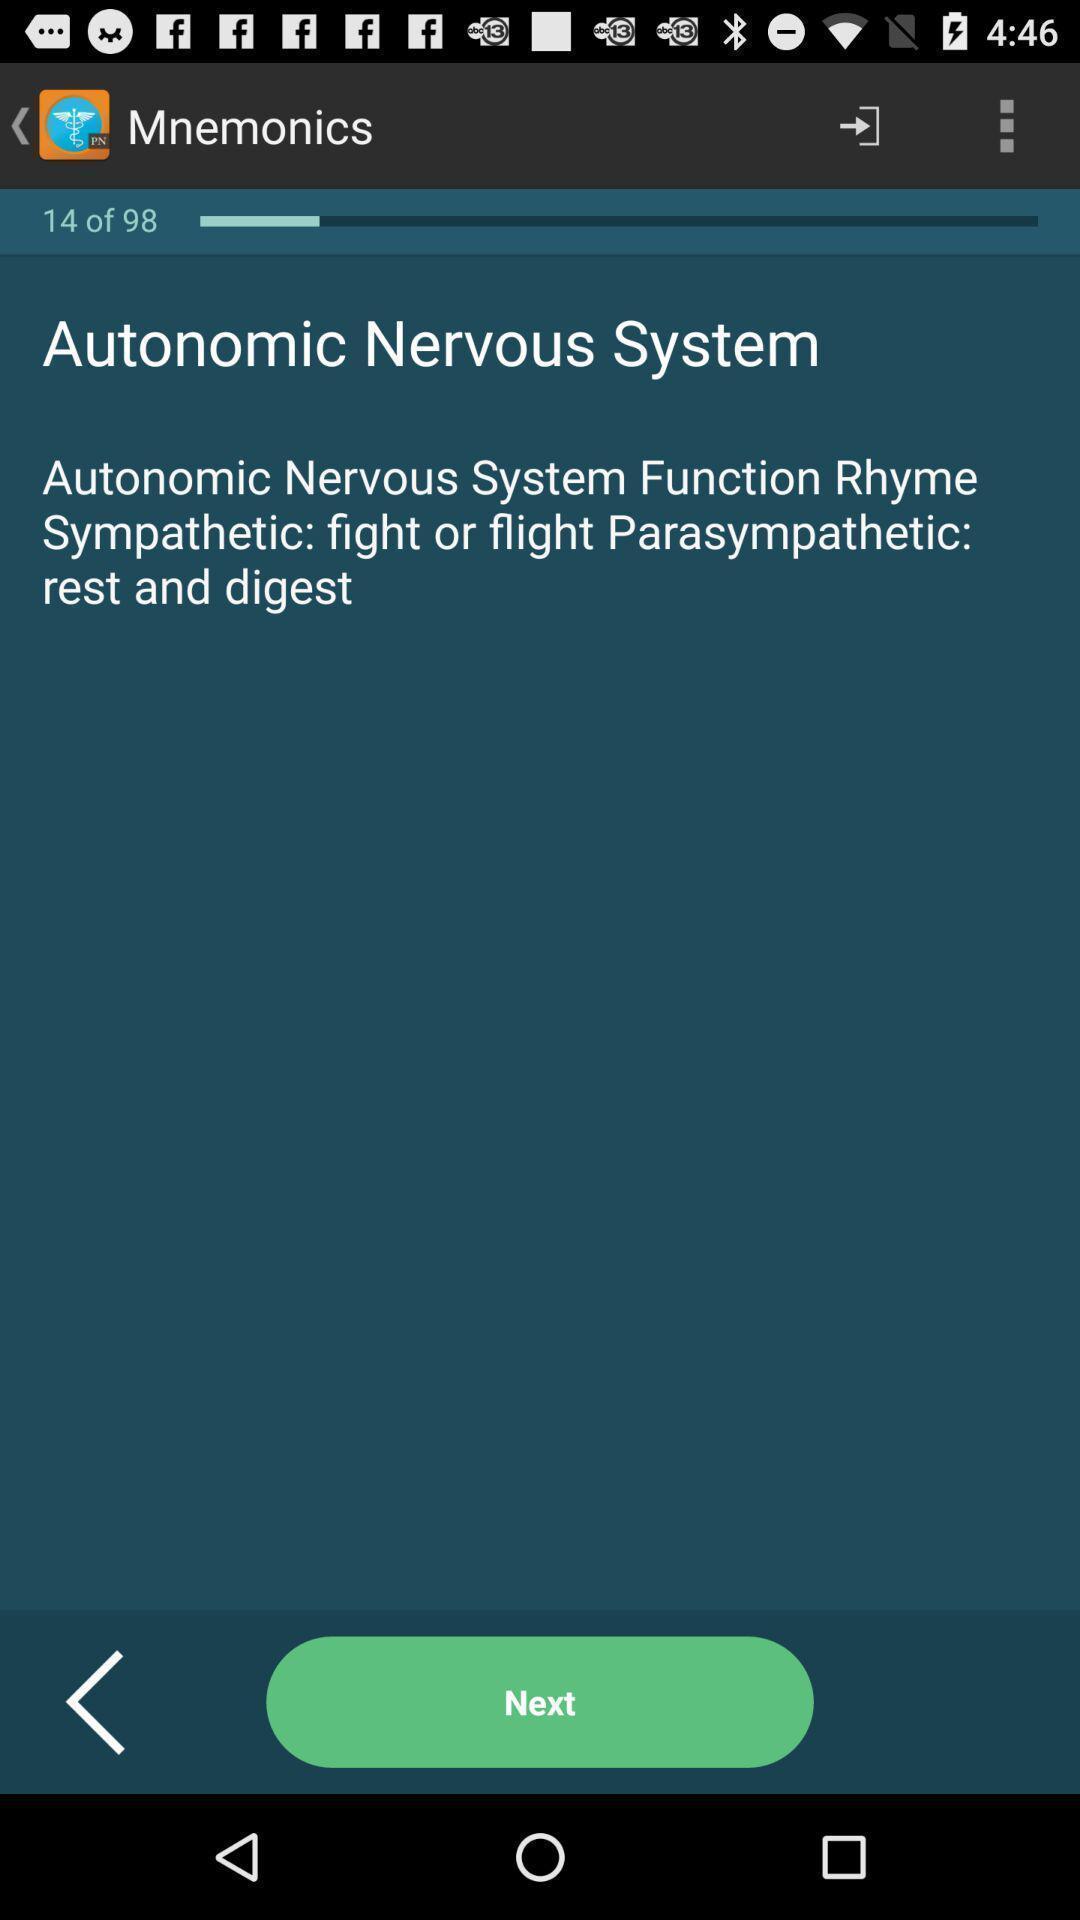Give me a narrative description of this picture. Screen shows download of mnemonics. 